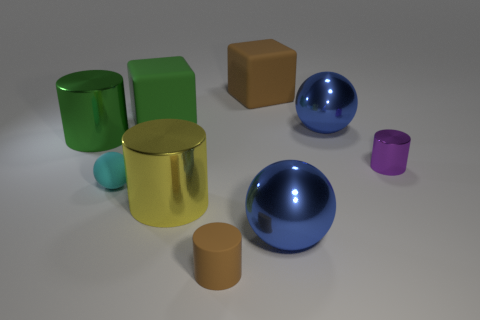Subtract all matte spheres. How many spheres are left? 2 Subtract all cubes. How many objects are left? 7 Subtract all purple cylinders. How many cylinders are left? 3 Subtract 3 spheres. How many spheres are left? 0 Subtract all blue balls. Subtract all red blocks. How many balls are left? 1 Subtract all yellow cylinders. How many gray spheres are left? 0 Subtract all rubber cylinders. Subtract all blue things. How many objects are left? 6 Add 4 spheres. How many spheres are left? 7 Add 9 big brown matte cubes. How many big brown matte cubes exist? 10 Subtract 0 green spheres. How many objects are left? 9 